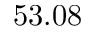Convert formula to latex. <formula><loc_0><loc_0><loc_500><loc_500>5 3 . 0 8</formula> 